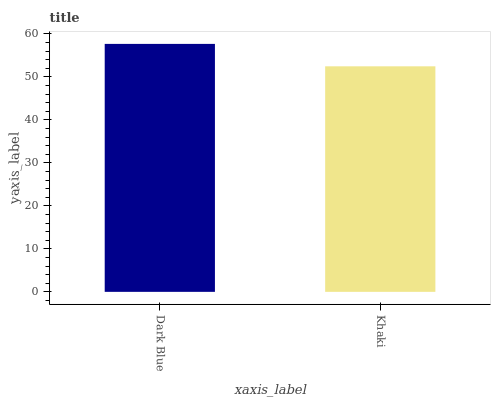Is Khaki the minimum?
Answer yes or no. Yes. Is Dark Blue the maximum?
Answer yes or no. Yes. Is Khaki the maximum?
Answer yes or no. No. Is Dark Blue greater than Khaki?
Answer yes or no. Yes. Is Khaki less than Dark Blue?
Answer yes or no. Yes. Is Khaki greater than Dark Blue?
Answer yes or no. No. Is Dark Blue less than Khaki?
Answer yes or no. No. Is Dark Blue the high median?
Answer yes or no. Yes. Is Khaki the low median?
Answer yes or no. Yes. Is Khaki the high median?
Answer yes or no. No. Is Dark Blue the low median?
Answer yes or no. No. 